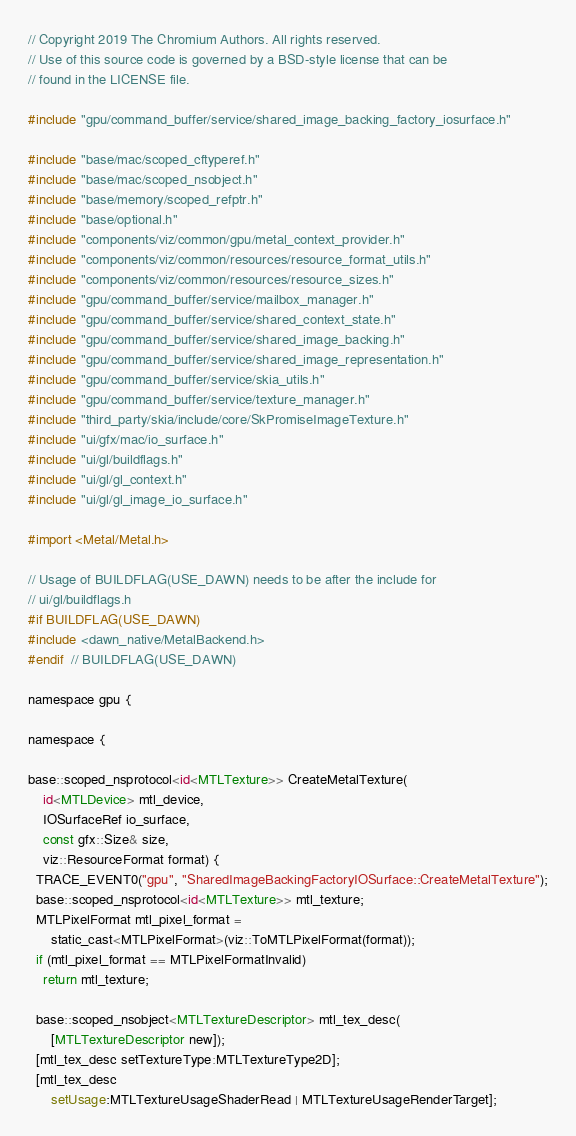<code> <loc_0><loc_0><loc_500><loc_500><_ObjectiveC_>// Copyright 2019 The Chromium Authors. All rights reserved.
// Use of this source code is governed by a BSD-style license that can be
// found in the LICENSE file.

#include "gpu/command_buffer/service/shared_image_backing_factory_iosurface.h"

#include "base/mac/scoped_cftyperef.h"
#include "base/mac/scoped_nsobject.h"
#include "base/memory/scoped_refptr.h"
#include "base/optional.h"
#include "components/viz/common/gpu/metal_context_provider.h"
#include "components/viz/common/resources/resource_format_utils.h"
#include "components/viz/common/resources/resource_sizes.h"
#include "gpu/command_buffer/service/mailbox_manager.h"
#include "gpu/command_buffer/service/shared_context_state.h"
#include "gpu/command_buffer/service/shared_image_backing.h"
#include "gpu/command_buffer/service/shared_image_representation.h"
#include "gpu/command_buffer/service/skia_utils.h"
#include "gpu/command_buffer/service/texture_manager.h"
#include "third_party/skia/include/core/SkPromiseImageTexture.h"
#include "ui/gfx/mac/io_surface.h"
#include "ui/gl/buildflags.h"
#include "ui/gl/gl_context.h"
#include "ui/gl/gl_image_io_surface.h"

#import <Metal/Metal.h>

// Usage of BUILDFLAG(USE_DAWN) needs to be after the include for
// ui/gl/buildflags.h
#if BUILDFLAG(USE_DAWN)
#include <dawn_native/MetalBackend.h>
#endif  // BUILDFLAG(USE_DAWN)

namespace gpu {

namespace {

base::scoped_nsprotocol<id<MTLTexture>> CreateMetalTexture(
    id<MTLDevice> mtl_device,
    IOSurfaceRef io_surface,
    const gfx::Size& size,
    viz::ResourceFormat format) {
  TRACE_EVENT0("gpu", "SharedImageBackingFactoryIOSurface::CreateMetalTexture");
  base::scoped_nsprotocol<id<MTLTexture>> mtl_texture;
  MTLPixelFormat mtl_pixel_format =
      static_cast<MTLPixelFormat>(viz::ToMTLPixelFormat(format));
  if (mtl_pixel_format == MTLPixelFormatInvalid)
    return mtl_texture;

  base::scoped_nsobject<MTLTextureDescriptor> mtl_tex_desc(
      [MTLTextureDescriptor new]);
  [mtl_tex_desc setTextureType:MTLTextureType2D];
  [mtl_tex_desc
      setUsage:MTLTextureUsageShaderRead | MTLTextureUsageRenderTarget];</code> 